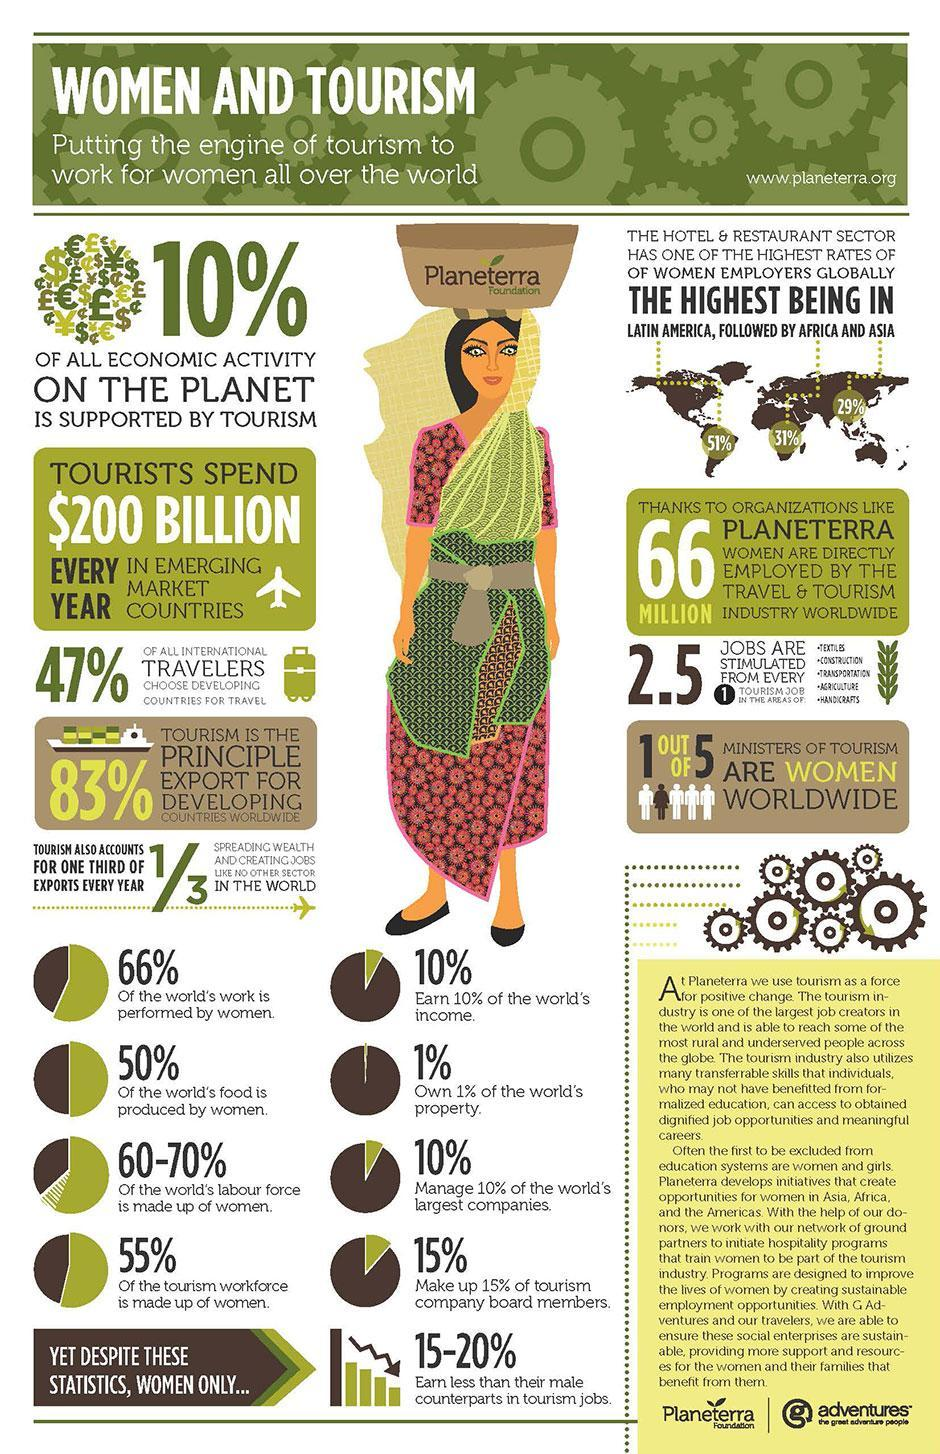What is the percentage of women employers rate in Africa?
Answer the question with a short phrase. 31% Out of 5, how many ministers of tourism are not women worldwide? 4 What percentage of the world's labor force made up of women? 60-70% Which continent has the third-highest rate of women employers? Asia What percentage of the tourism workforce not made up of women? 45% Which continent has the second-highest rate of women employers? Africa What is the percentage of women employers rate in Latin America? 51% What percentage of the world's work is not performed by women? 34% What is the percentage of women employers rate in Asia? 29% What percentage of the world's food is not produced by women? 50% 